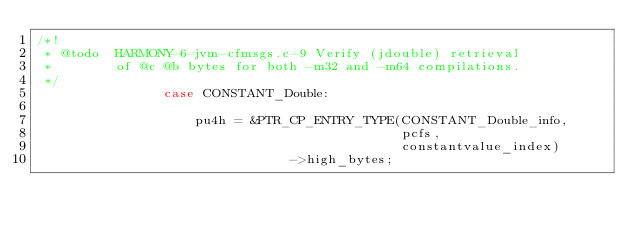<code> <loc_0><loc_0><loc_500><loc_500><_C_>/*!
 * @todo  HARMONY-6-jvm-cfmsgs.c-9 Verify (jdouble) retrieval
 *        of @c @b bytes for both -m32 and -m64 compilations.
 */
                case CONSTANT_Double:

                    pu4h = &PTR_CP_ENTRY_TYPE(CONSTANT_Double_info,
                                              pcfs,
                                              constantvalue_index)
                                ->high_bytes;</code> 